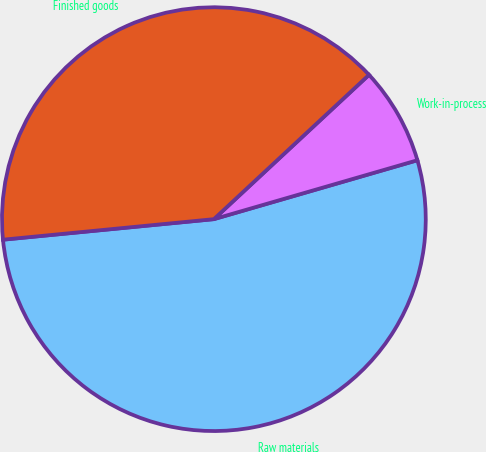Convert chart to OTSL. <chart><loc_0><loc_0><loc_500><loc_500><pie_chart><fcel>Raw materials<fcel>Work-in-process<fcel>Finished goods<nl><fcel>52.94%<fcel>7.44%<fcel>39.62%<nl></chart> 